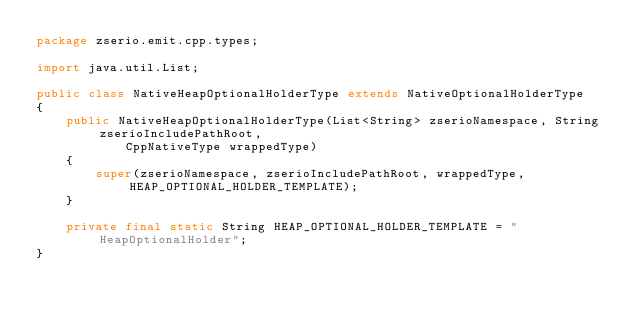Convert code to text. <code><loc_0><loc_0><loc_500><loc_500><_Java_>package zserio.emit.cpp.types;

import java.util.List;

public class NativeHeapOptionalHolderType extends NativeOptionalHolderType
{
    public NativeHeapOptionalHolderType(List<String> zserioNamespace, String zserioIncludePathRoot,
            CppNativeType wrappedType)
    {
        super(zserioNamespace, zserioIncludePathRoot, wrappedType, HEAP_OPTIONAL_HOLDER_TEMPLATE);
    }

    private final static String HEAP_OPTIONAL_HOLDER_TEMPLATE = "HeapOptionalHolder";
}
</code> 